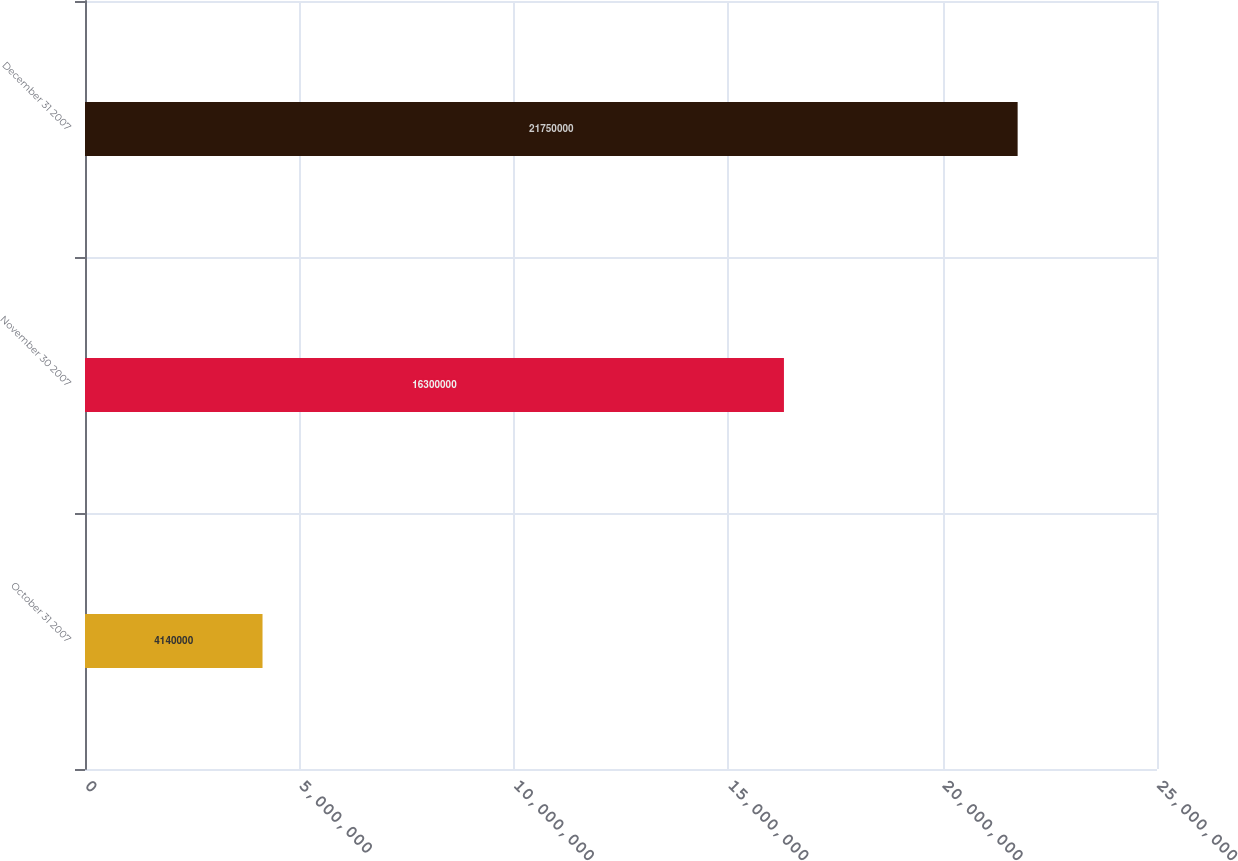<chart> <loc_0><loc_0><loc_500><loc_500><bar_chart><fcel>October 31 2007<fcel>November 30 2007<fcel>December 31 2007<nl><fcel>4.14e+06<fcel>1.63e+07<fcel>2.175e+07<nl></chart> 